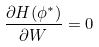<formula> <loc_0><loc_0><loc_500><loc_500>\frac { \partial H ( \phi ^ { * } ) } { \partial W } = 0</formula> 